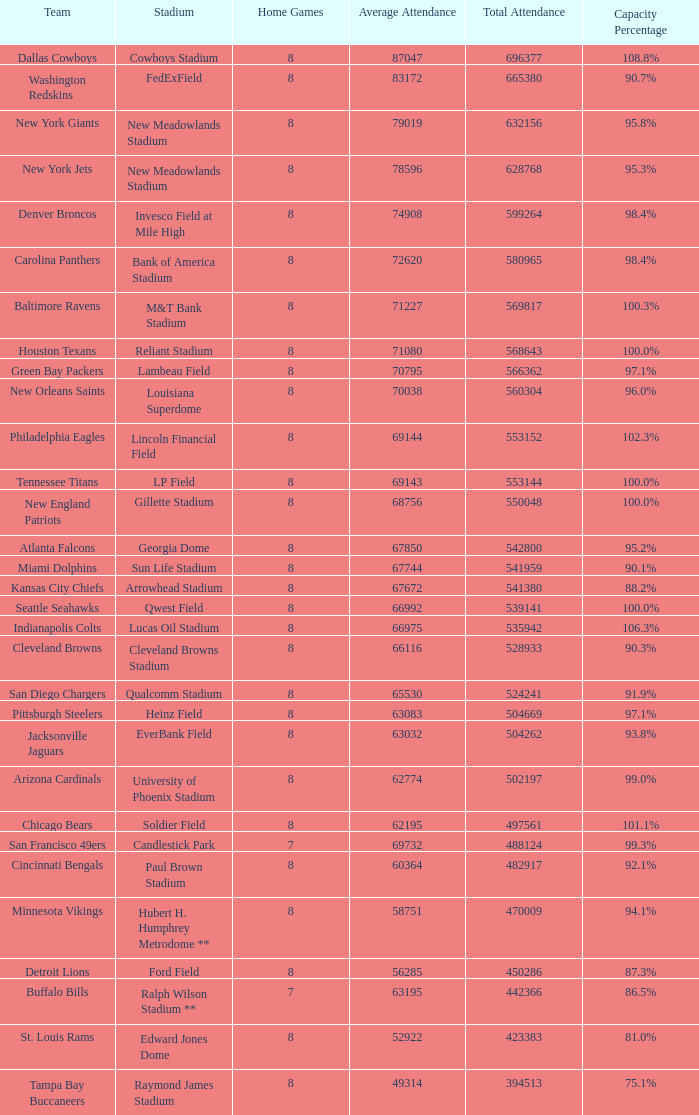What was the capacity for the Denver Broncos? 98.4%. 